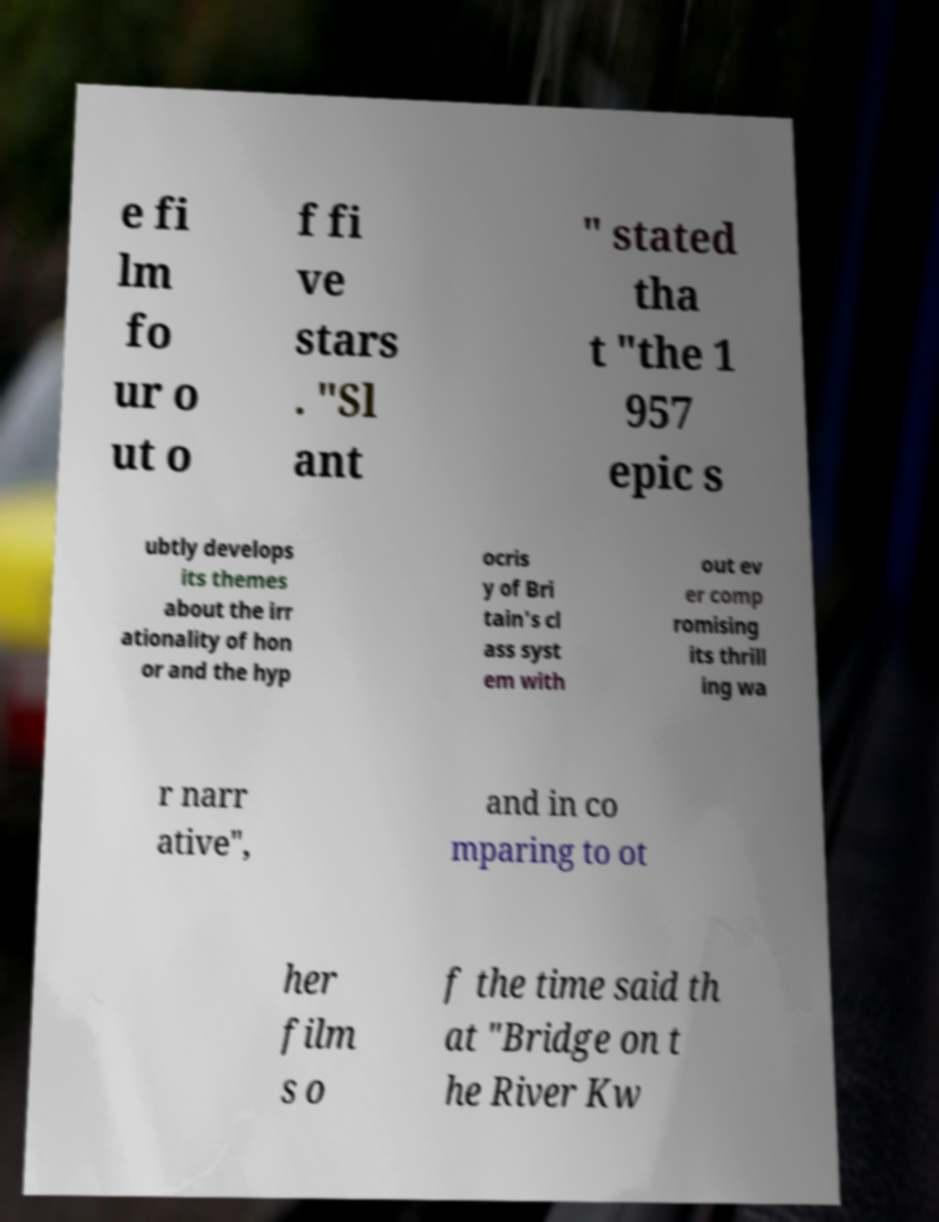Can you accurately transcribe the text from the provided image for me? e fi lm fo ur o ut o f fi ve stars . "Sl ant " stated tha t "the 1 957 epic s ubtly develops its themes about the irr ationality of hon or and the hyp ocris y of Bri tain's cl ass syst em with out ev er comp romising its thrill ing wa r narr ative", and in co mparing to ot her film s o f the time said th at "Bridge on t he River Kw 